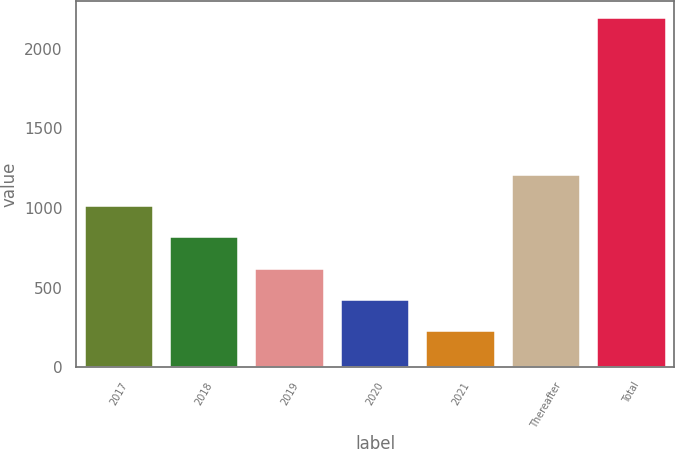<chart> <loc_0><loc_0><loc_500><loc_500><bar_chart><fcel>2017<fcel>2018<fcel>2019<fcel>2020<fcel>2021<fcel>Thereafter<fcel>Total<nl><fcel>1012.68<fcel>816.11<fcel>619.54<fcel>422.97<fcel>226.4<fcel>1209.25<fcel>2192.1<nl></chart> 